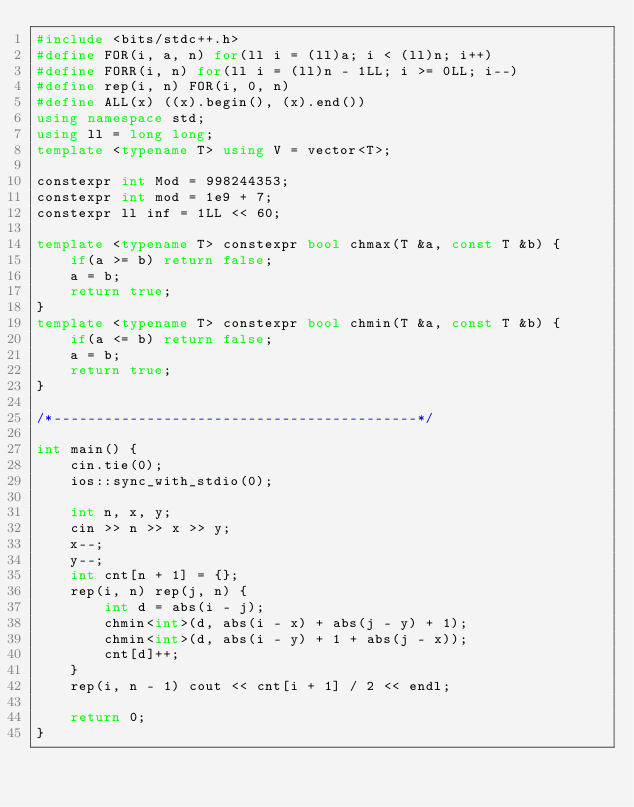Convert code to text. <code><loc_0><loc_0><loc_500><loc_500><_C++_>#include <bits/stdc++.h>
#define FOR(i, a, n) for(ll i = (ll)a; i < (ll)n; i++)
#define FORR(i, n) for(ll i = (ll)n - 1LL; i >= 0LL; i--)
#define rep(i, n) FOR(i, 0, n)
#define ALL(x) ((x).begin(), (x).end())
using namespace std;
using ll = long long;
template <typename T> using V = vector<T>;

constexpr int Mod = 998244353;
constexpr int mod = 1e9 + 7;
constexpr ll inf = 1LL << 60;

template <typename T> constexpr bool chmax(T &a, const T &b) {
    if(a >= b) return false;
    a = b;
    return true;
}
template <typename T> constexpr bool chmin(T &a, const T &b) {
    if(a <= b) return false;
    a = b;
    return true;
}

/*-------------------------------------------*/

int main() {
    cin.tie(0);
    ios::sync_with_stdio(0);

    int n, x, y;
    cin >> n >> x >> y;
    x--;
    y--;
    int cnt[n + 1] = {};
    rep(i, n) rep(j, n) {
        int d = abs(i - j);
        chmin<int>(d, abs(i - x) + abs(j - y) + 1);
        chmin<int>(d, abs(i - y) + 1 + abs(j - x));
        cnt[d]++;
    }
    rep(i, n - 1) cout << cnt[i + 1] / 2 << endl;

    return 0;
}</code> 